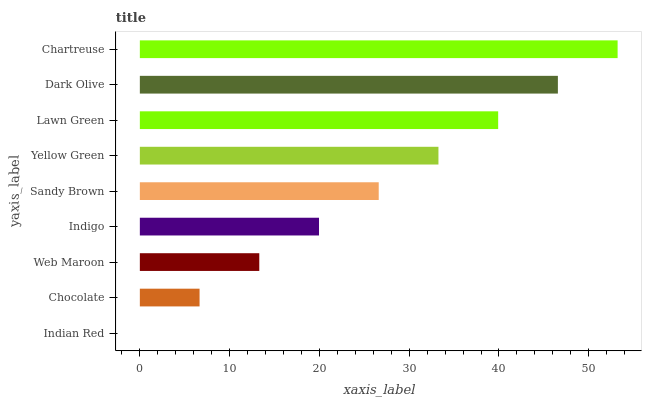Is Indian Red the minimum?
Answer yes or no. Yes. Is Chartreuse the maximum?
Answer yes or no. Yes. Is Chocolate the minimum?
Answer yes or no. No. Is Chocolate the maximum?
Answer yes or no. No. Is Chocolate greater than Indian Red?
Answer yes or no. Yes. Is Indian Red less than Chocolate?
Answer yes or no. Yes. Is Indian Red greater than Chocolate?
Answer yes or no. No. Is Chocolate less than Indian Red?
Answer yes or no. No. Is Sandy Brown the high median?
Answer yes or no. Yes. Is Sandy Brown the low median?
Answer yes or no. Yes. Is Dark Olive the high median?
Answer yes or no. No. Is Chartreuse the low median?
Answer yes or no. No. 